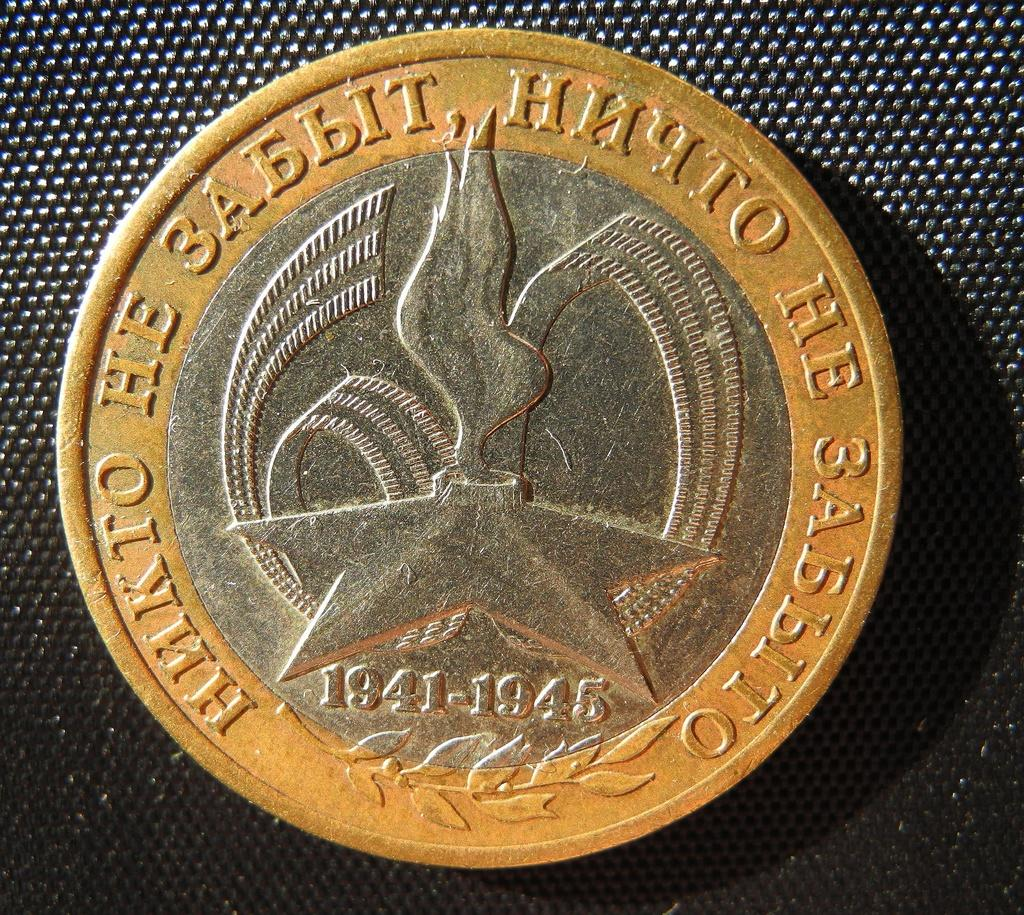What object can be seen in the image? There is a coin in the image. How many mines are present in the image? There are no mines present in the image; it features a coin. How many brothers are depicted in the image? There are no people, including brothers, present in the image; it features a coin. 